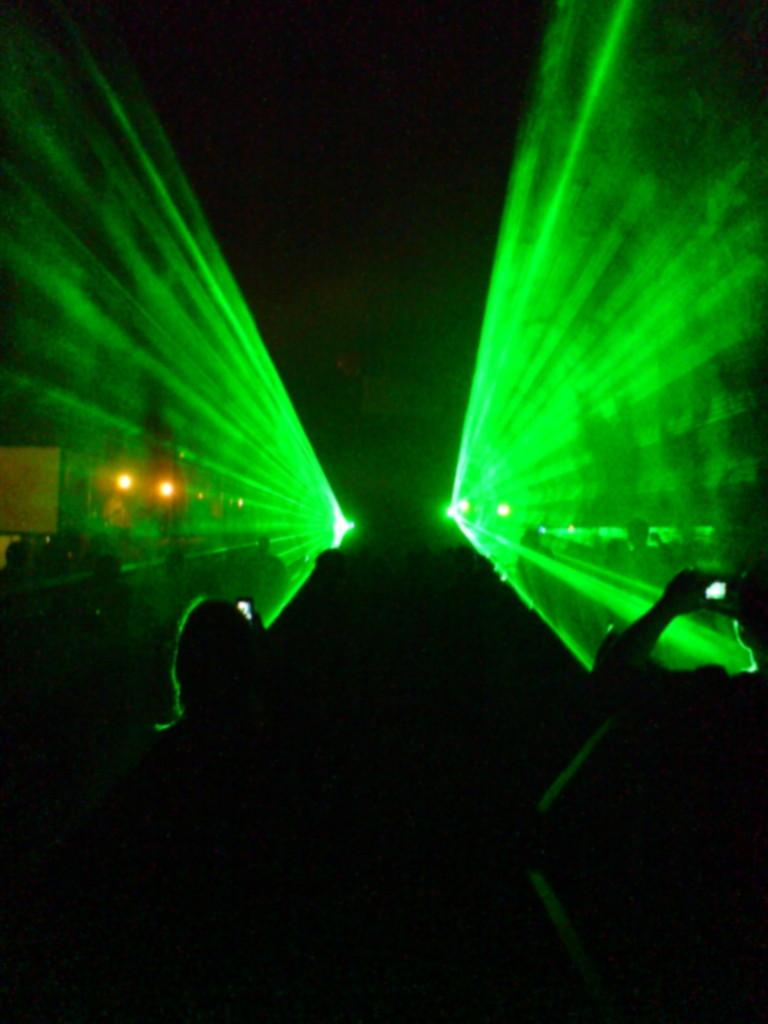What can be seen at the bottom of the image? There are people at the bottom of the image. What are some of the people doing in the image? Some of the people are holding mobiles. What is visible at the top of the image? There are lights visible at the top of the image. How many snakes are slithering around the people in the image? There are no snakes present in the image. What is the amount of quills used to create the lights at the top of the image? The image does not provide information about the materials used to create the lights, so we cannot determine the amount of quills used. 